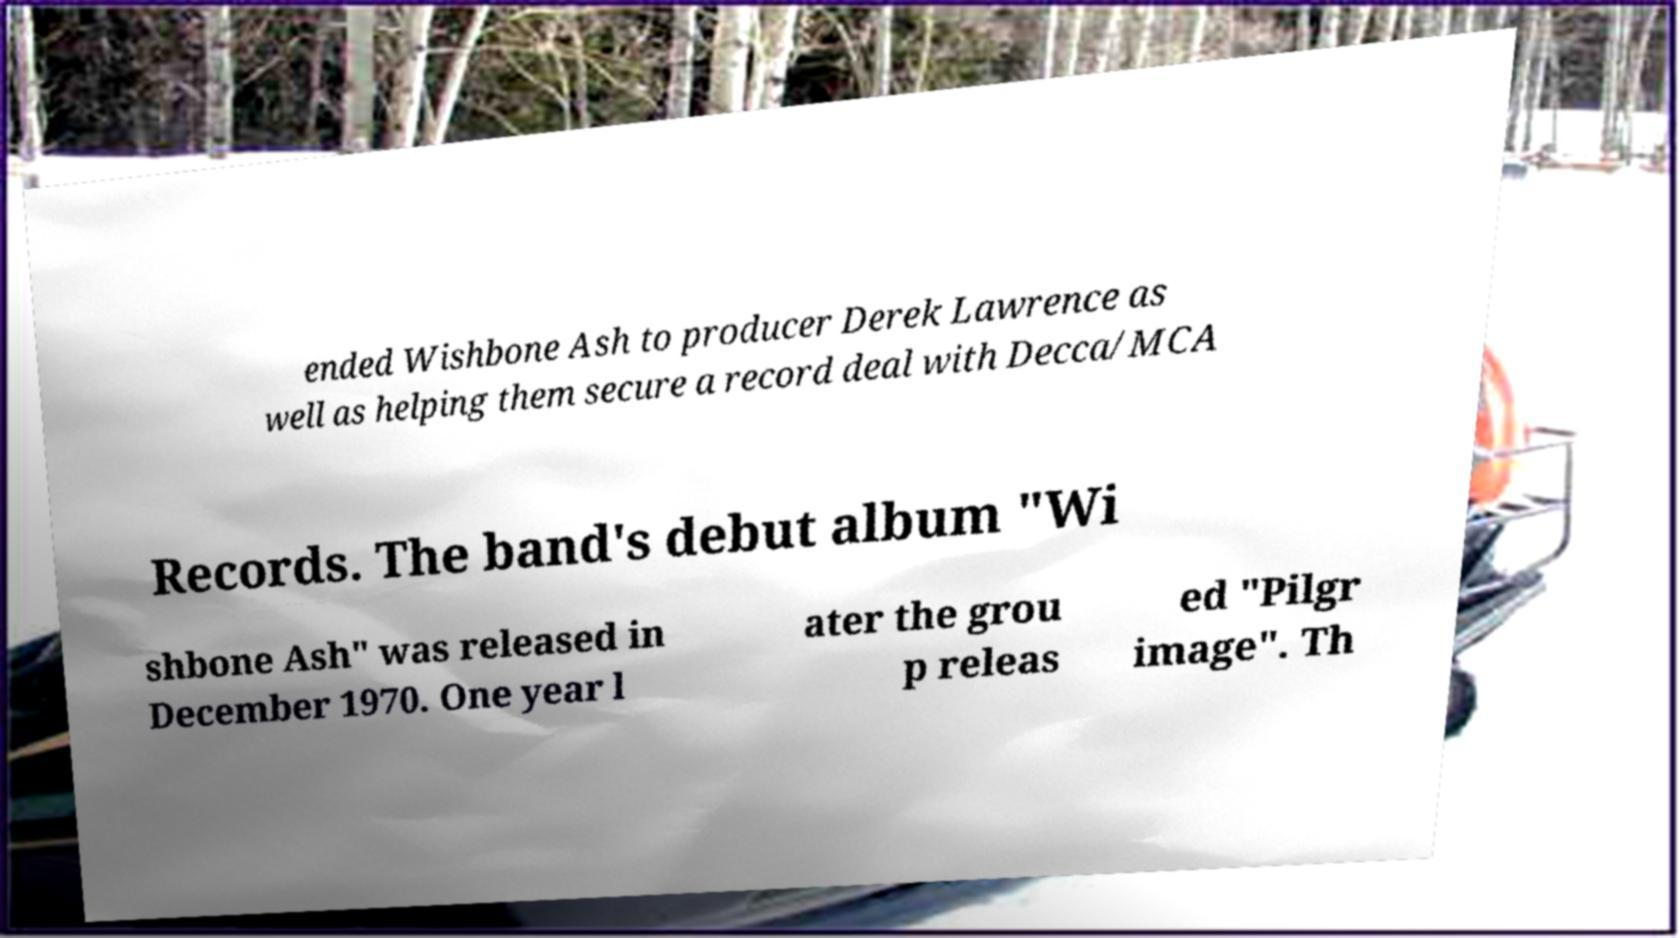Could you assist in decoding the text presented in this image and type it out clearly? ended Wishbone Ash to producer Derek Lawrence as well as helping them secure a record deal with Decca/MCA Records. The band's debut album "Wi shbone Ash" was released in December 1970. One year l ater the grou p releas ed "Pilgr image". Th 